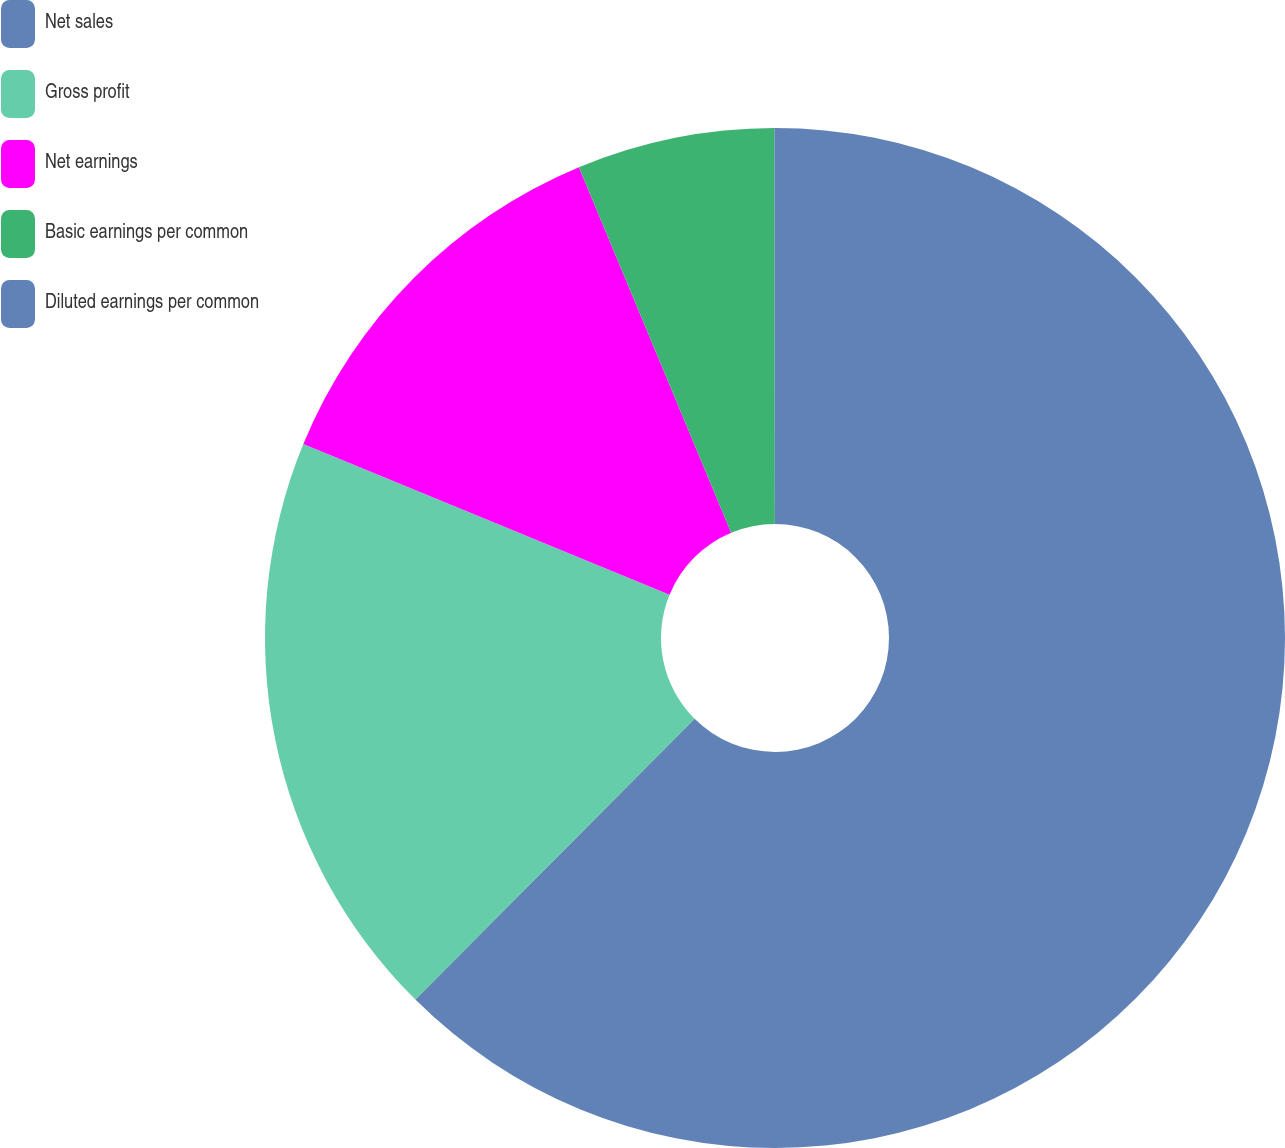<chart> <loc_0><loc_0><loc_500><loc_500><pie_chart><fcel>Net sales<fcel>Gross profit<fcel>Net earnings<fcel>Basic earnings per common<fcel>Diluted earnings per common<nl><fcel>62.45%<fcel>18.75%<fcel>12.51%<fcel>6.26%<fcel>0.02%<nl></chart> 